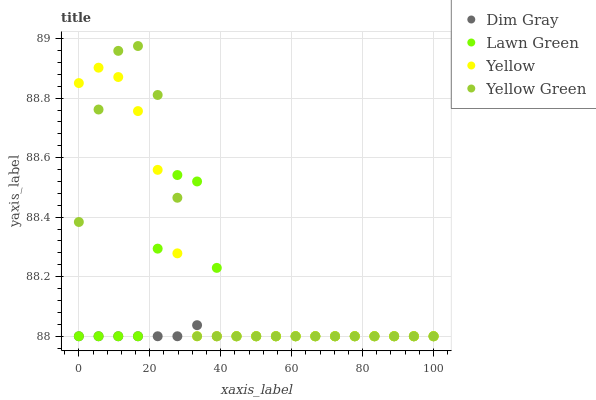Does Dim Gray have the minimum area under the curve?
Answer yes or no. Yes. Does Yellow Green have the maximum area under the curve?
Answer yes or no. Yes. Does Yellow Green have the minimum area under the curve?
Answer yes or no. No. Does Dim Gray have the maximum area under the curve?
Answer yes or no. No. Is Dim Gray the smoothest?
Answer yes or no. Yes. Is Yellow Green the roughest?
Answer yes or no. Yes. Is Yellow Green the smoothest?
Answer yes or no. No. Is Dim Gray the roughest?
Answer yes or no. No. Does Lawn Green have the lowest value?
Answer yes or no. Yes. Does Yellow Green have the highest value?
Answer yes or no. Yes. Does Dim Gray have the highest value?
Answer yes or no. No. Does Dim Gray intersect Yellow?
Answer yes or no. Yes. Is Dim Gray less than Yellow?
Answer yes or no. No. Is Dim Gray greater than Yellow?
Answer yes or no. No. 